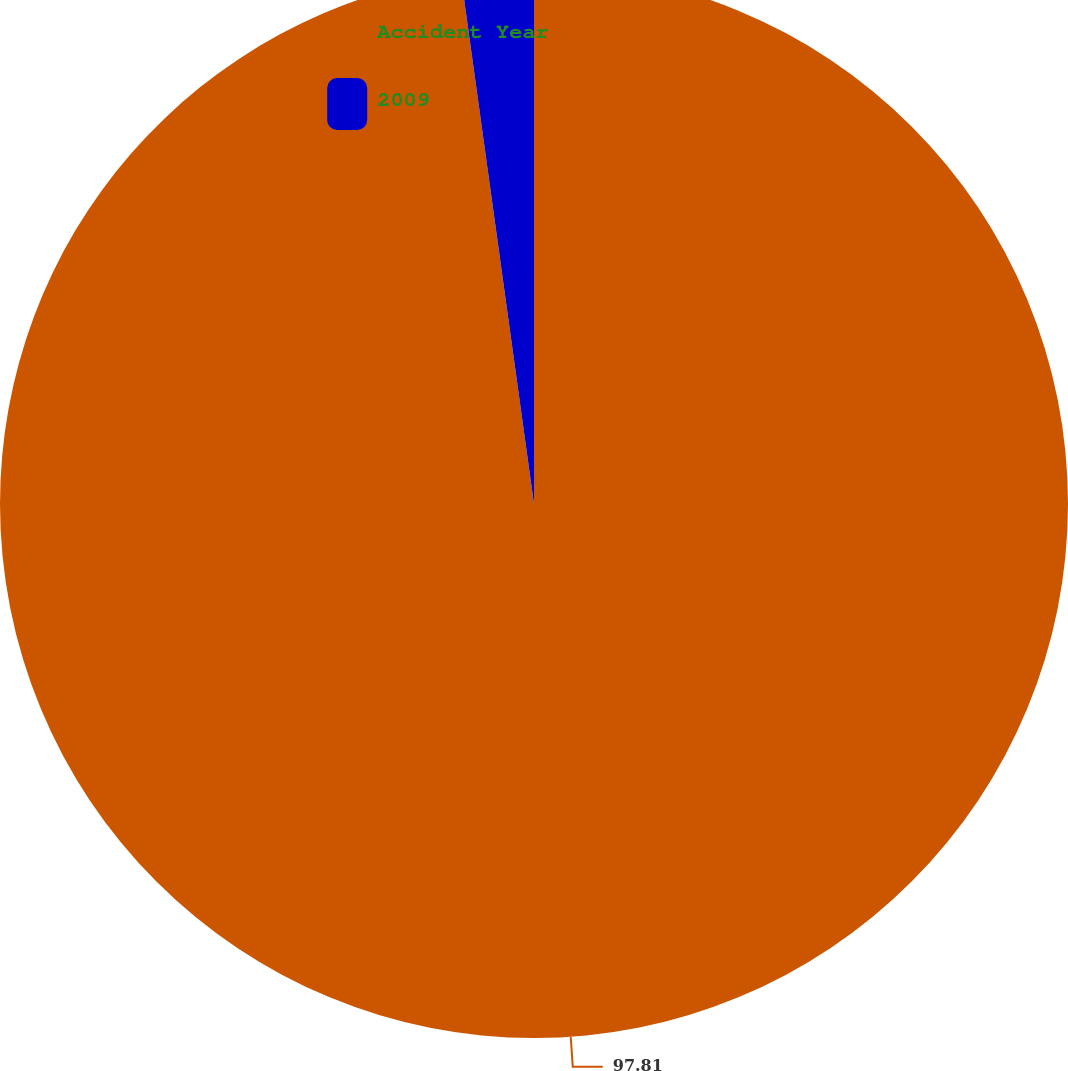Convert chart to OTSL. <chart><loc_0><loc_0><loc_500><loc_500><pie_chart><fcel>Accident Year<fcel>2009<nl><fcel>97.81%<fcel>2.19%<nl></chart> 